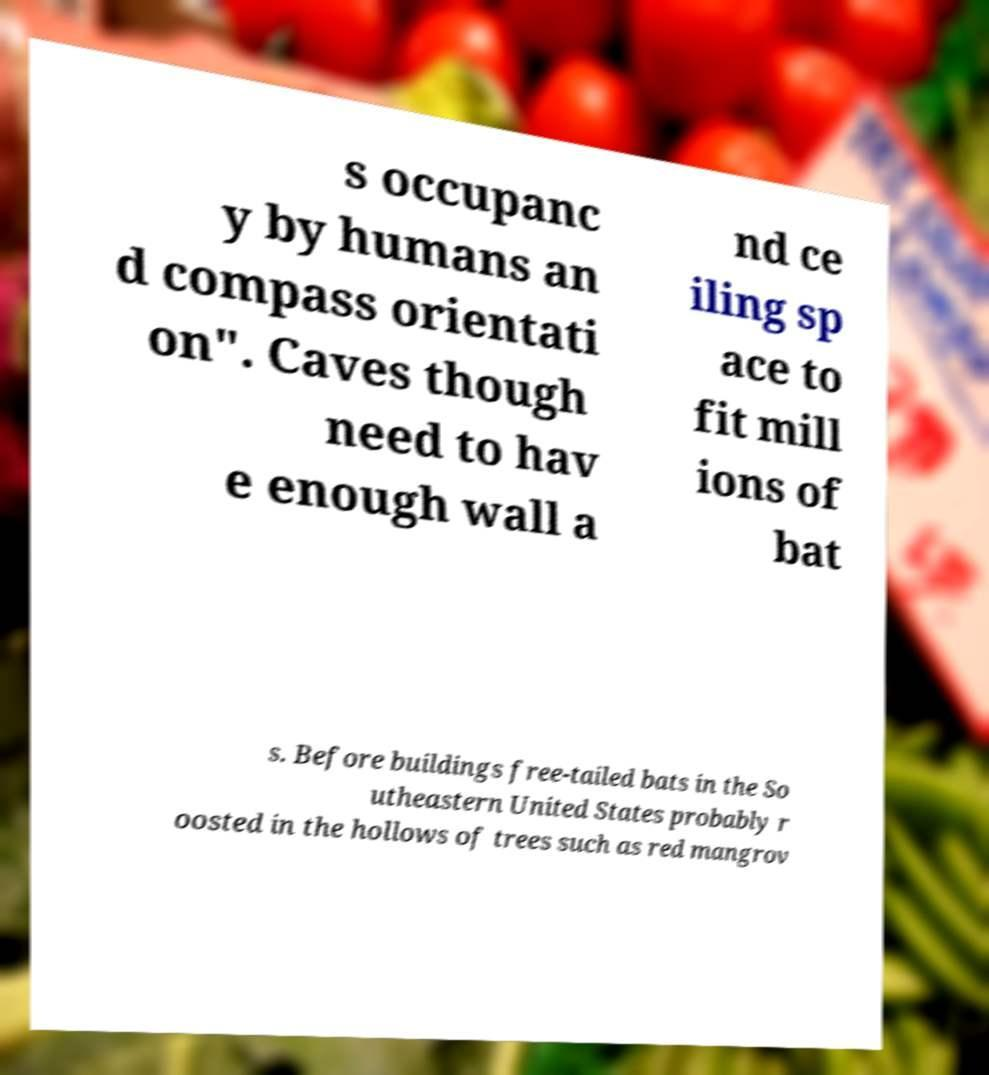What messages or text are displayed in this image? I need them in a readable, typed format. s occupanc y by humans an d compass orientati on". Caves though need to hav e enough wall a nd ce iling sp ace to fit mill ions of bat s. Before buildings free-tailed bats in the So utheastern United States probably r oosted in the hollows of trees such as red mangrov 